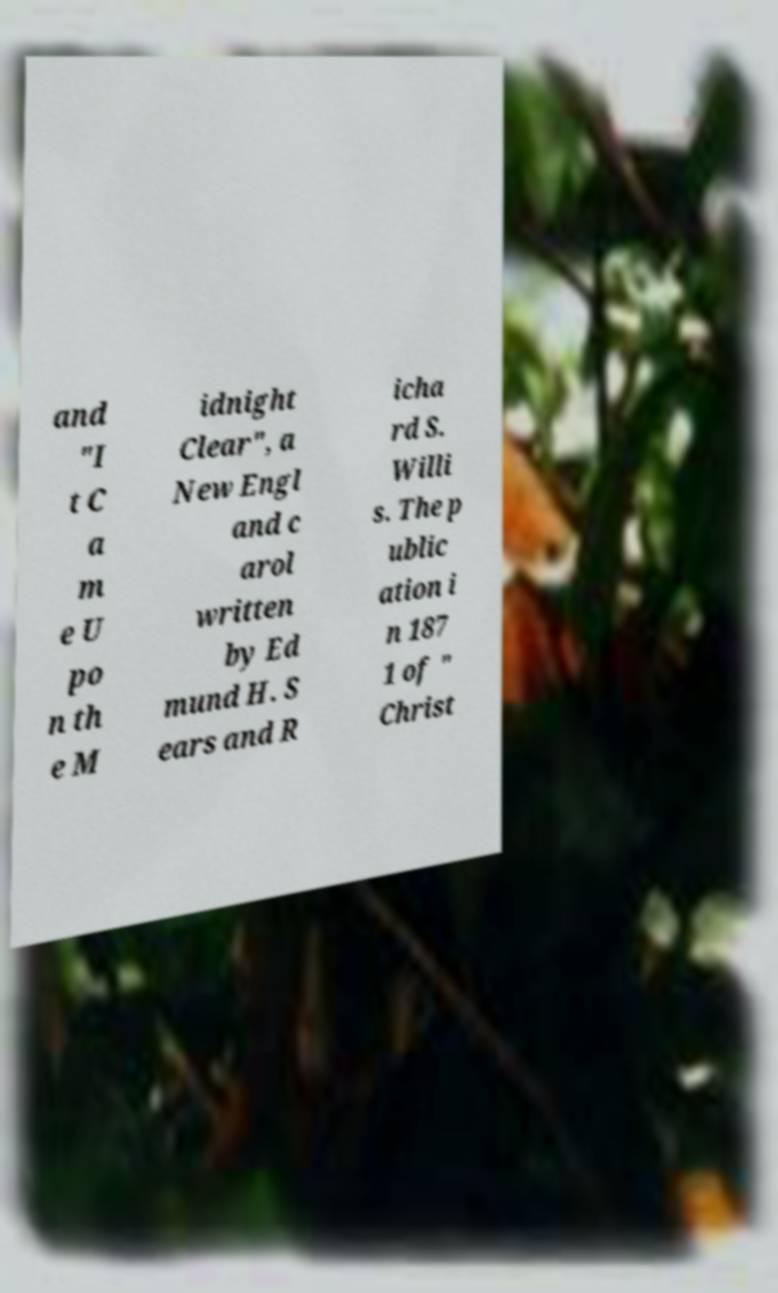Please read and relay the text visible in this image. What does it say? and "I t C a m e U po n th e M idnight Clear", a New Engl and c arol written by Ed mund H. S ears and R icha rd S. Willi s. The p ublic ation i n 187 1 of " Christ 